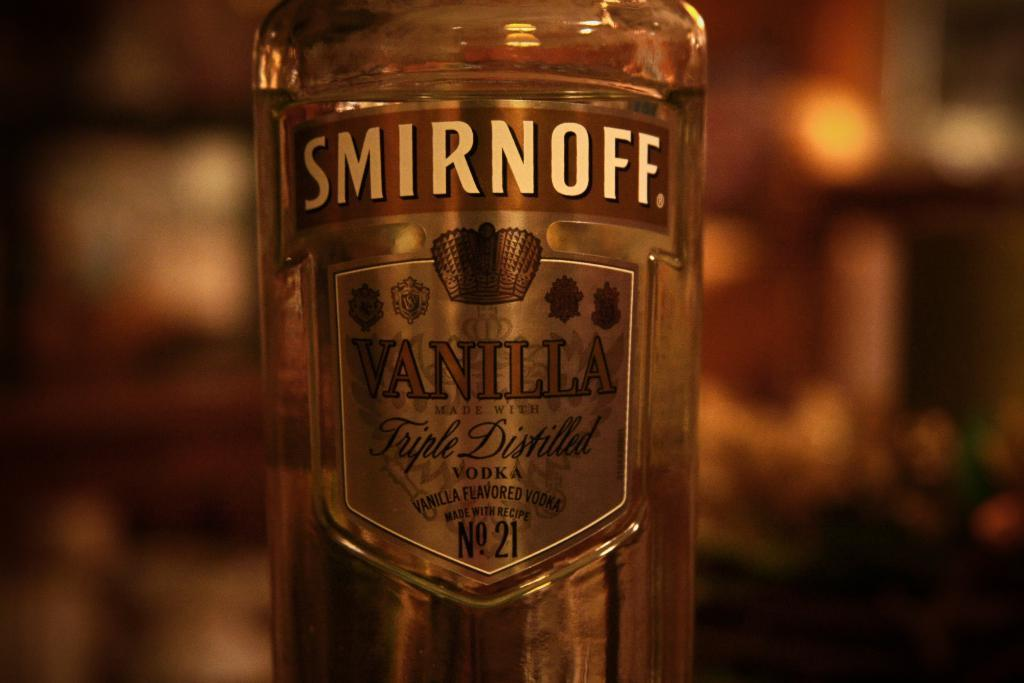<image>
Create a compact narrative representing the image presented. A bottle of Smirnoff Vanilla Triple distilled vodka. 